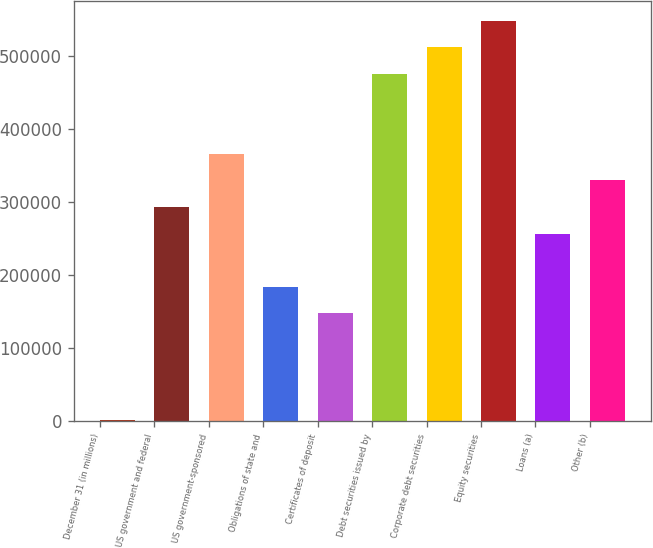Convert chart. <chart><loc_0><loc_0><loc_500><loc_500><bar_chart><fcel>December 31 (in millions)<fcel>US government and federal<fcel>US government-sponsored<fcel>Obligations of state and<fcel>Certificates of deposit<fcel>Debt securities issued by<fcel>Corporate debt securities<fcel>Equity securities<fcel>Loans (a)<fcel>Other (b)<nl><fcel>2006<fcel>292992<fcel>365738<fcel>183872<fcel>147499<fcel>474858<fcel>511231<fcel>547604<fcel>256618<fcel>329365<nl></chart> 